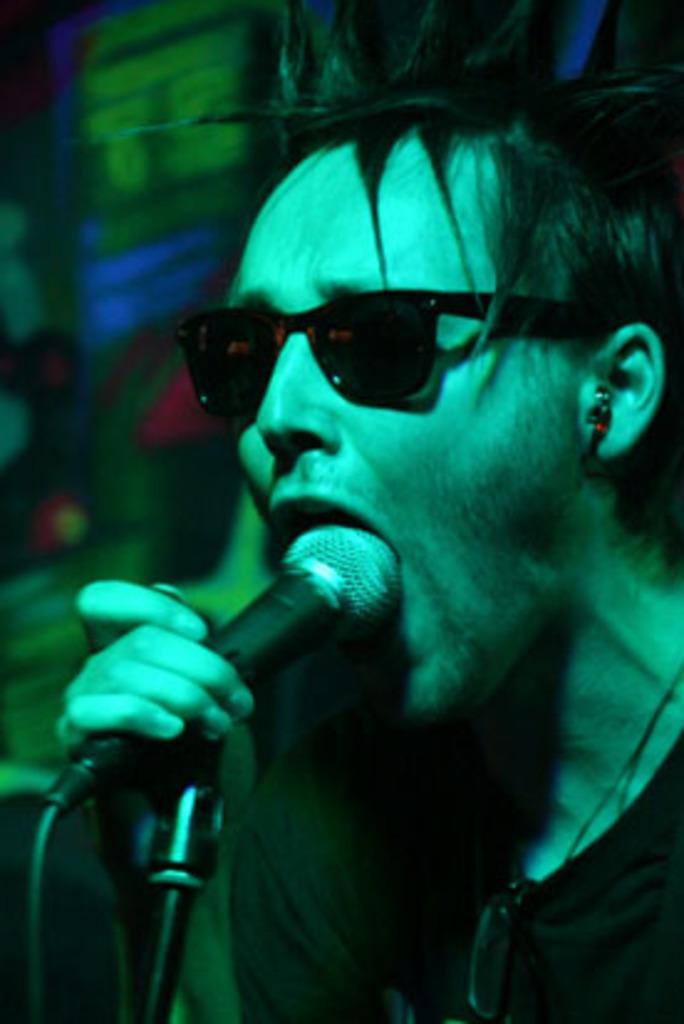Could you give a brief overview of what you see in this image? In the foreground of this picture we can see a person wearing sunglasses, holding a microphone and in the background we can see many other objects. 